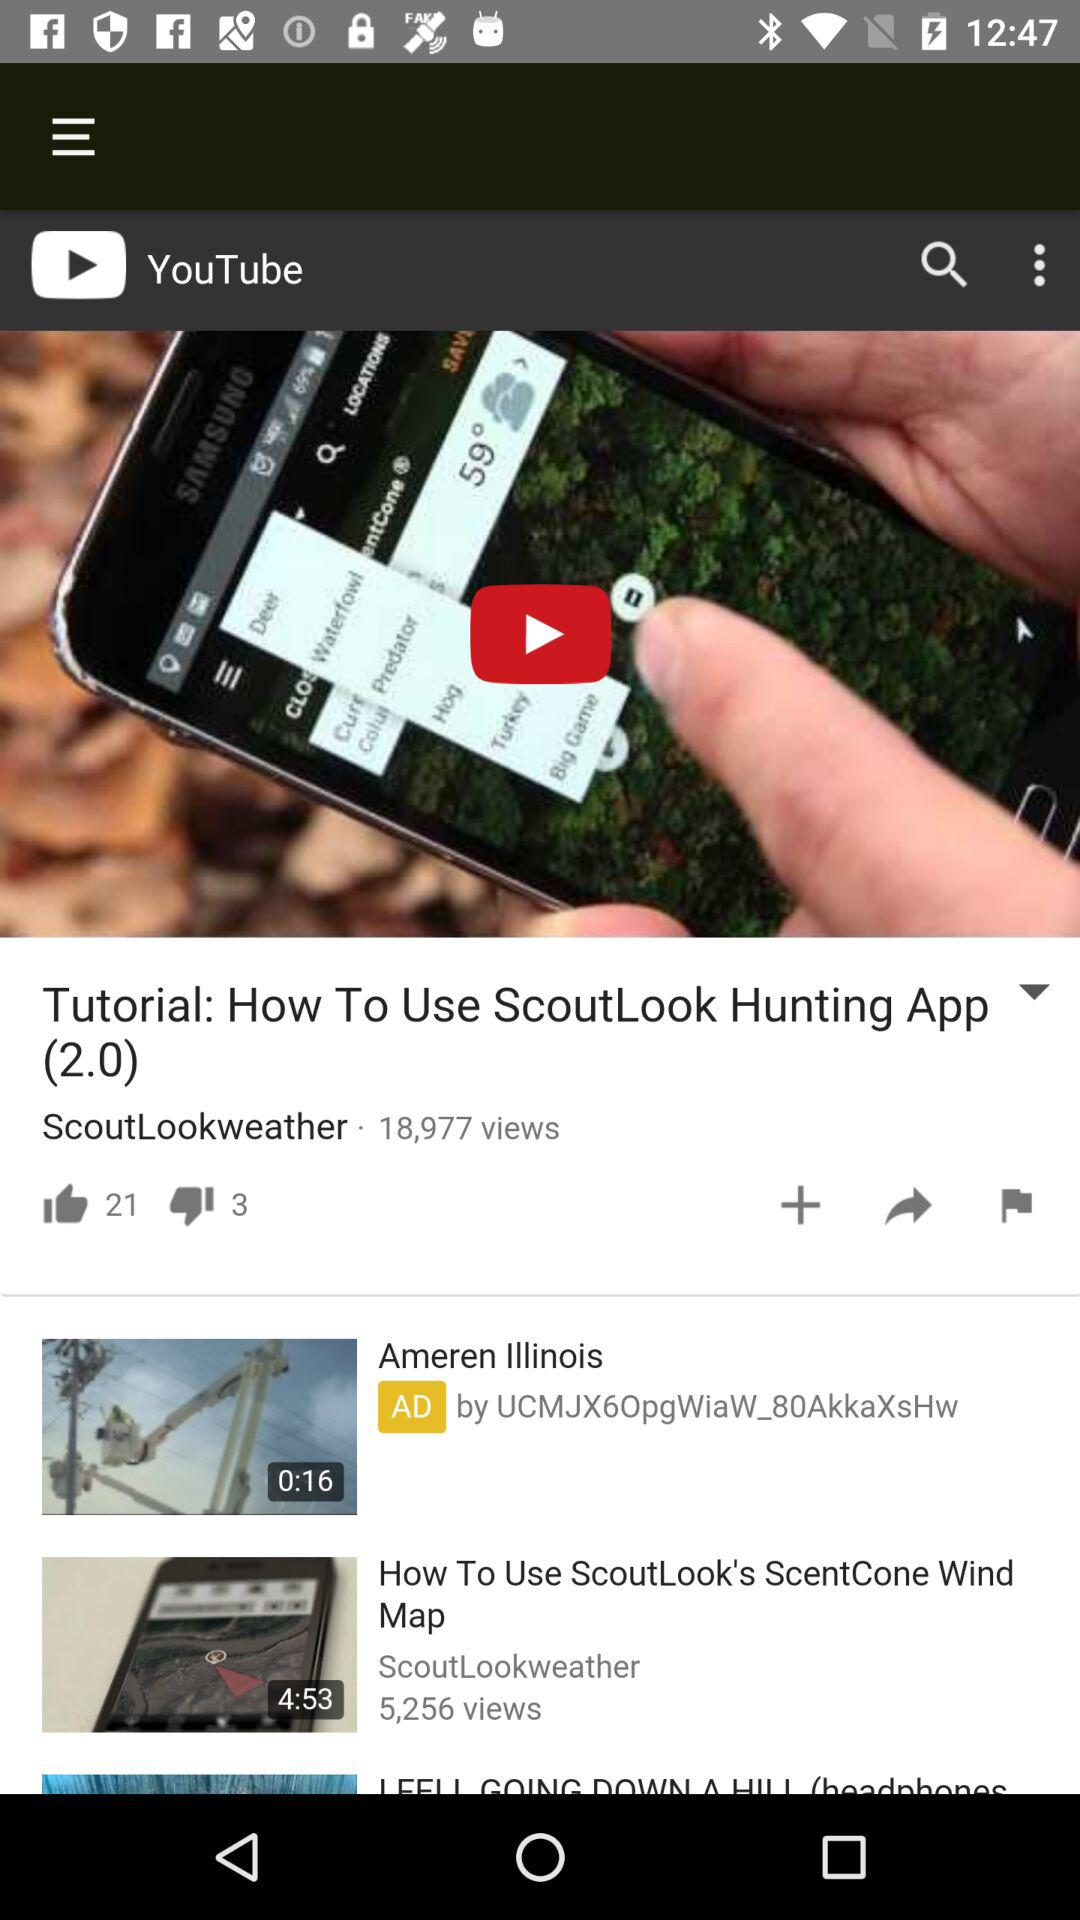How many views in total are there for "Tutorial: How To Use ScoutLook Hunting App (2.0)"? There are 18,977 views. 